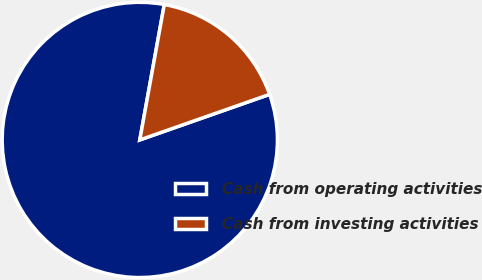Convert chart to OTSL. <chart><loc_0><loc_0><loc_500><loc_500><pie_chart><fcel>Cash from operating activities<fcel>Cash from investing activities<nl><fcel>83.22%<fcel>16.78%<nl></chart> 